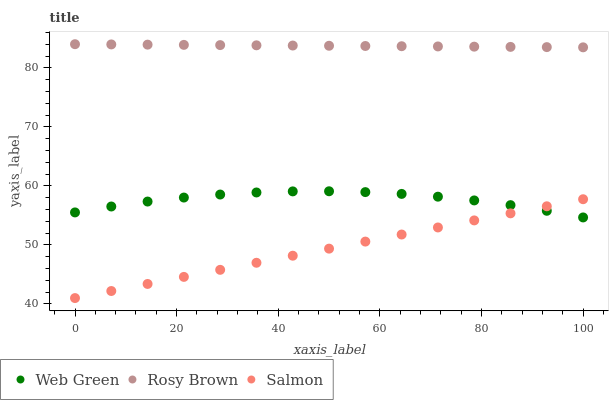Does Salmon have the minimum area under the curve?
Answer yes or no. Yes. Does Rosy Brown have the maximum area under the curve?
Answer yes or no. Yes. Does Web Green have the minimum area under the curve?
Answer yes or no. No. Does Web Green have the maximum area under the curve?
Answer yes or no. No. Is Rosy Brown the smoothest?
Answer yes or no. Yes. Is Web Green the roughest?
Answer yes or no. Yes. Is Salmon the smoothest?
Answer yes or no. No. Is Salmon the roughest?
Answer yes or no. No. Does Salmon have the lowest value?
Answer yes or no. Yes. Does Web Green have the lowest value?
Answer yes or no. No. Does Rosy Brown have the highest value?
Answer yes or no. Yes. Does Web Green have the highest value?
Answer yes or no. No. Is Salmon less than Rosy Brown?
Answer yes or no. Yes. Is Rosy Brown greater than Web Green?
Answer yes or no. Yes. Does Salmon intersect Web Green?
Answer yes or no. Yes. Is Salmon less than Web Green?
Answer yes or no. No. Is Salmon greater than Web Green?
Answer yes or no. No. Does Salmon intersect Rosy Brown?
Answer yes or no. No. 